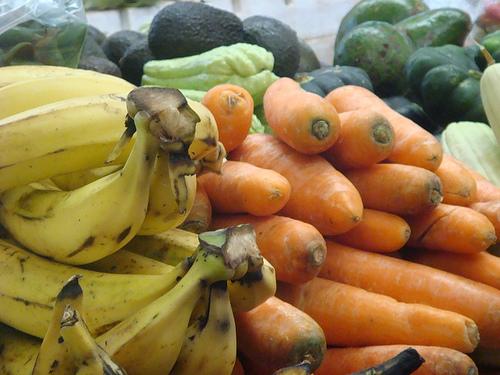Are the bananas ripe enough to eat?
Short answer required. Yes. Are the bananas ripe?
Quick response, please. Yes. Will they eat the carrot like that?
Write a very short answer. No. Is this most likely at a farmers market or a grocery store?
Answer briefly. Farmers market. 